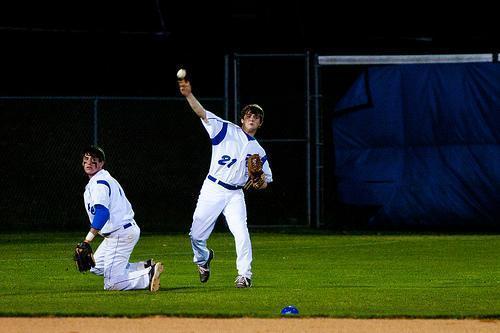How many players are in the picture?
Give a very brief answer. 2. 